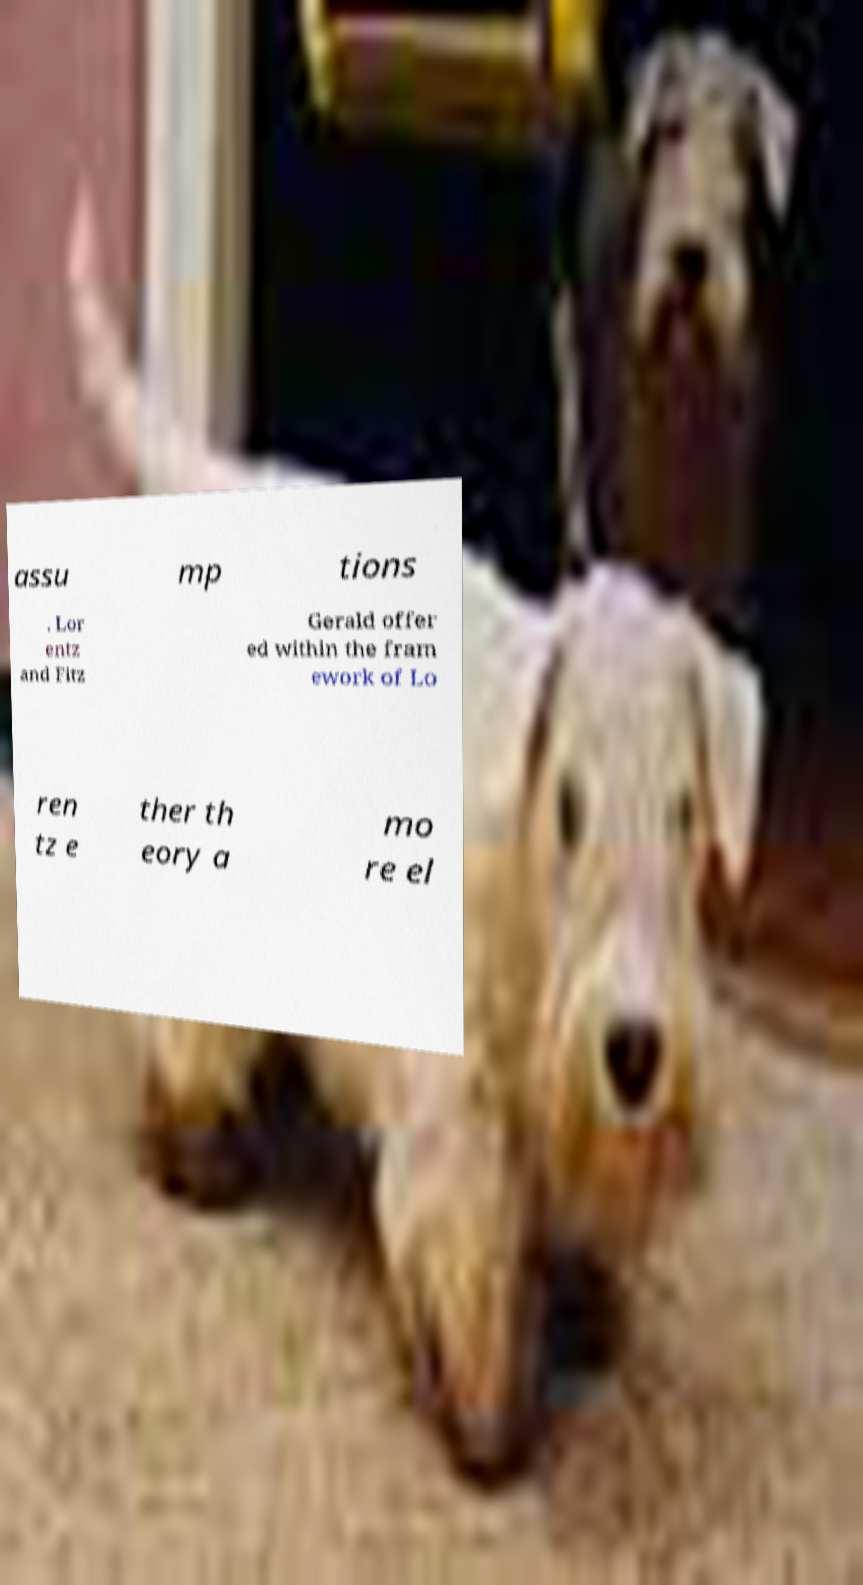There's text embedded in this image that I need extracted. Can you transcribe it verbatim? assu mp tions . Lor entz and Fitz Gerald offer ed within the fram ework of Lo ren tz e ther th eory a mo re el 